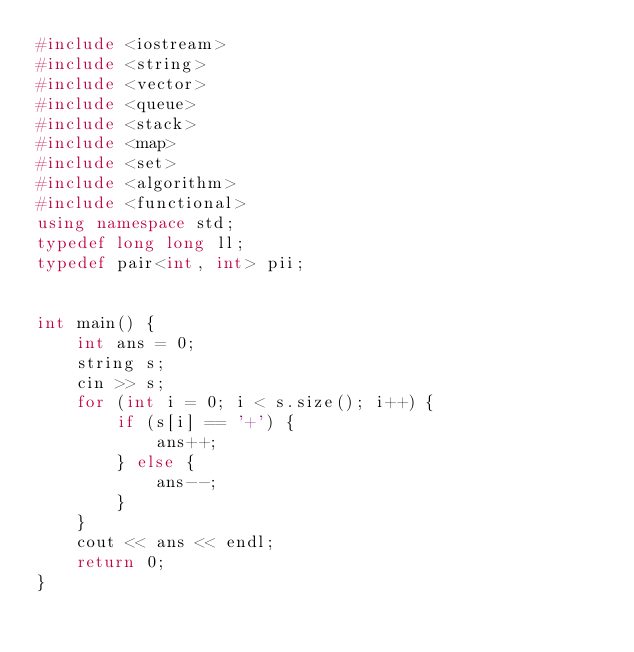Convert code to text. <code><loc_0><loc_0><loc_500><loc_500><_C++_>#include <iostream>
#include <string>
#include <vector>
#include <queue>
#include <stack>
#include <map>
#include <set>
#include <algorithm>
#include <functional>
using namespace std;
typedef long long ll;
typedef pair<int, int> pii;
 
 
int main() {
    int ans = 0;
    string s;
    cin >> s;
    for (int i = 0; i < s.size(); i++) {
        if (s[i] == '+') {
            ans++;
        } else {
            ans--;
        }
    }
    cout << ans << endl;
    return 0;
}
</code> 